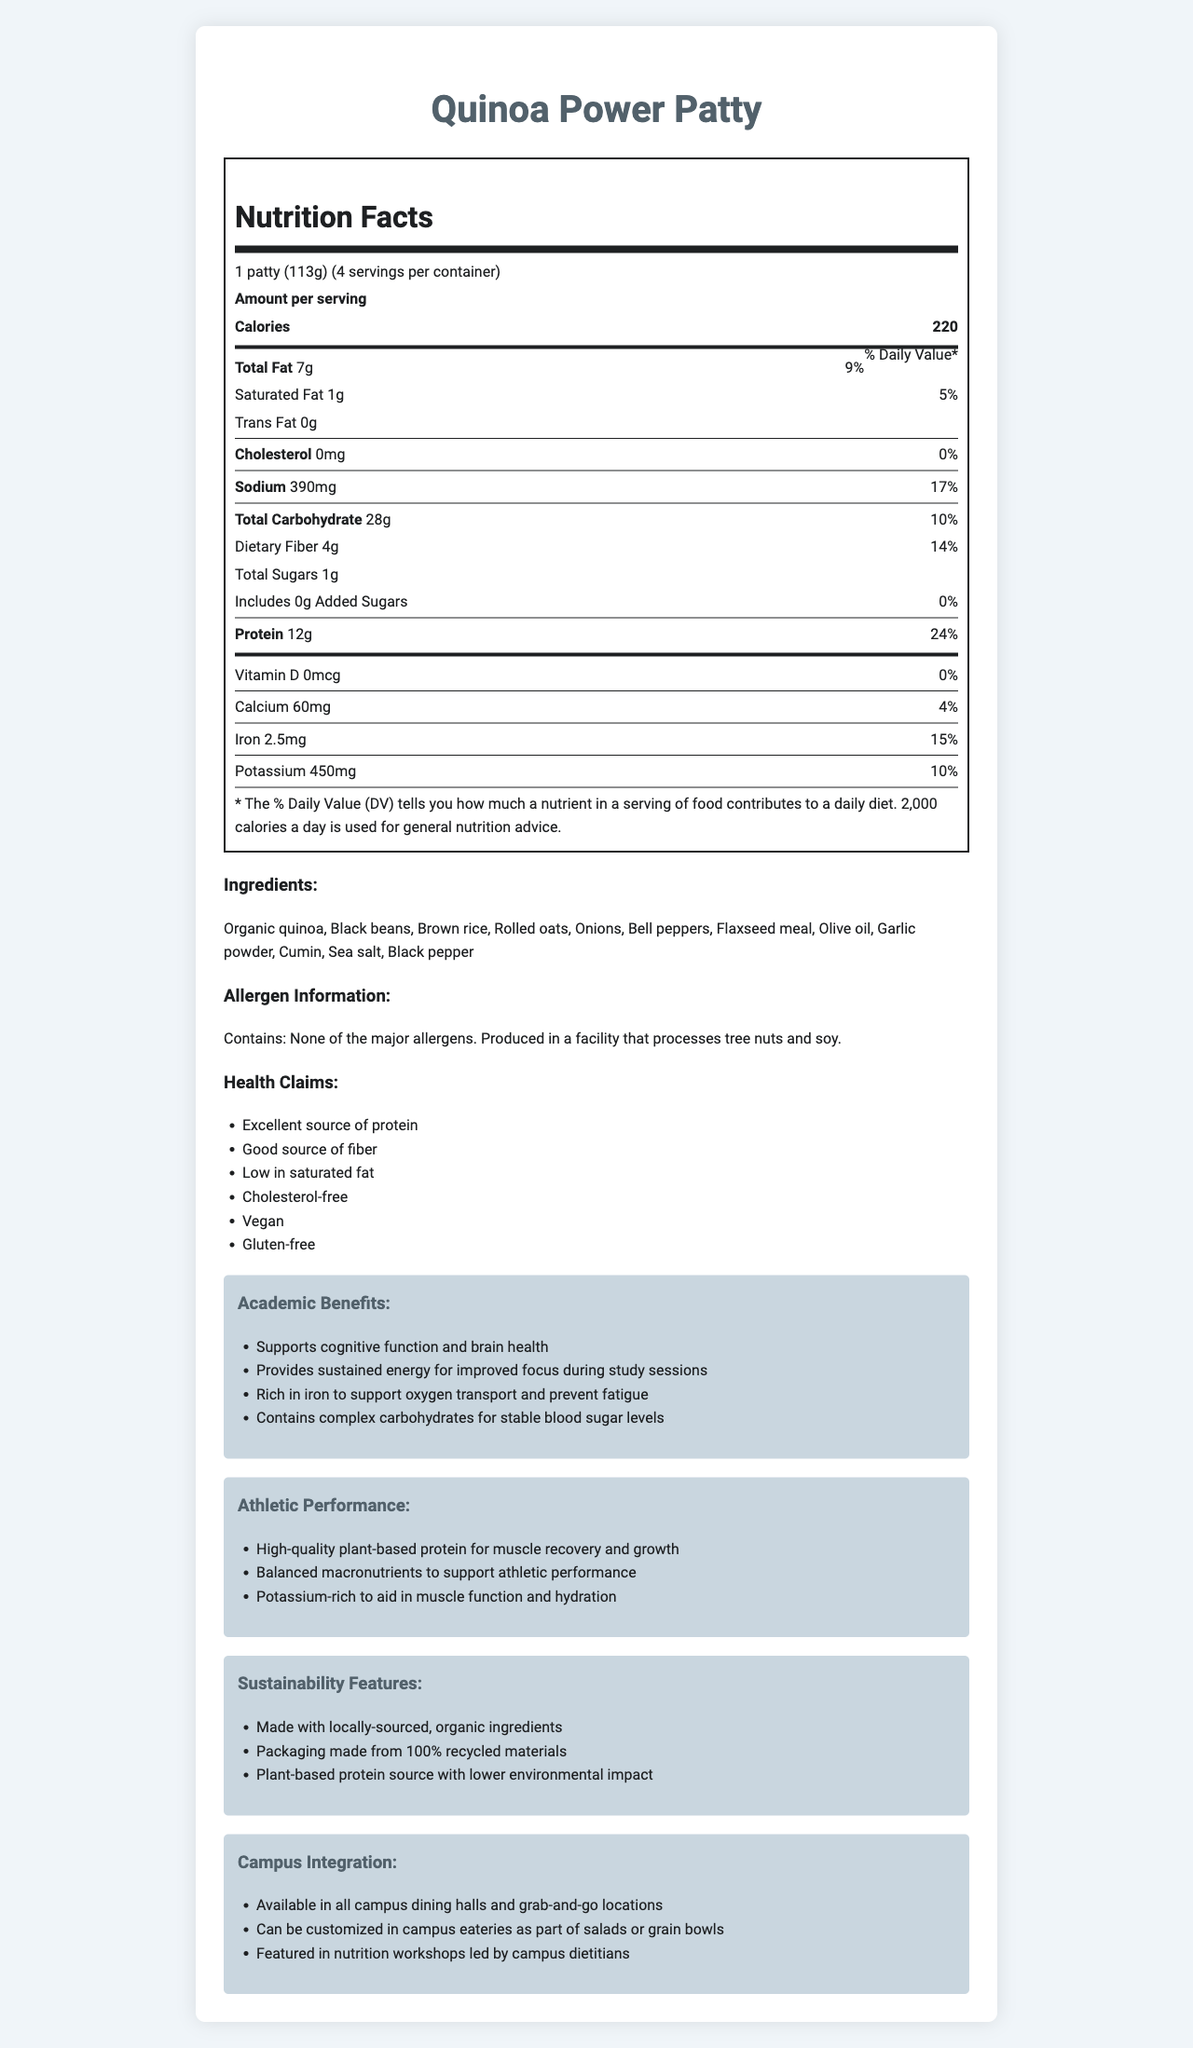When was the "Quinoa Power Patty" being produced? The document does not contain any information about the production date of the "Quinoa Power Patty".
Answer: Not enough information What is the serving size of the Quinoa Power Patty? The serving size is clearly stated as "1 patty (113g)" in the nutrition facts section.
Answer: 1 patty (113g) How many calories are in one serving of Quinoa Power Patty? The document specifies that one serving contains 220 calories.
Answer: 220 calories What percentage of the daily value of protein does a serving provide? The nutrition facts indicate that one serving provides 24% of the daily value for protein.
Answer: 24% Is the Quinoa Power Patty cholesterol-free? The nutrition facts label shows that the Quinoa Power Patty has 0mg of cholesterol, stating it as "Cholesterol-free".
Answer: Yes What is the main idea of the document? This document includes the product name, serving size, nutritional facts, ingredients, allergen information, health claims, academic benefits, athletic performance features, sustainability features, and campus integration information related to the Quinoa Power Patty.
Answer: The document provides detailed nutritional information, ingredients, health benefits, and campus integration details for the "Quinoa Power Patty," a vegetarian protein source designed to support diverse dietary needs on campus. How much dietary fiber does one serving contain? The nutrition label specifies that one serving contains 4g of dietary fiber.
Answer: 4g What are the ingredients of Quinoa Power Patty? The document lists all the ingredients under the "Ingredients" section.
Answer: Organic quinoa, Black beans, Brown rice, Rolled oats, Onions, Bell peppers, Flaxseed meal, Olive oil, Garlic powder, Cumin, Sea salt, Black pepper  The athletic performance section lists "High-quality plant-based protein for muscle recovery and growth," "Balanced macronutrients to support athletic performance," and "Potassium-rich to aid in muscle function and hydration," but does not mention promoting relaxation.
Answer: B. Promotes relaxation  The document mentions specific health claims including "Low in saturated fat," while it is also noted to be cholesterol-free and has 0g of added sugars which disqualifies options 1 and 3.
Answer: 2. Low in saturated fat Can the document tell if the Quinoa Power Patty is suitable for gluten intolerant individuals? The document lists "gluten-free" as one of its health claims, indicating it is suitable for those who are gluten intolerant.
Answer: Yes What are some of the sustainability features of the Quinoa Power Patty? The document explicitly lists these sustainability features in the "Sustainability Features" section.
Answer: Made with locally-sourced, organic ingredients; Packaging made from 100% recycled materials; Plant-based protein source with lower environmental impact Where can students find the Quinoa Power Patty on campus? According to the "Campus Integration" section, these are the places and ways the Quinoa Power Patty is integrated into the campus food services.
Answer: Available in all campus dining halls and grab-and-go locations; Can be customized in campus eateries as part of salads or grain bowls; Featured in nutrition workshops led by campus dietitians 